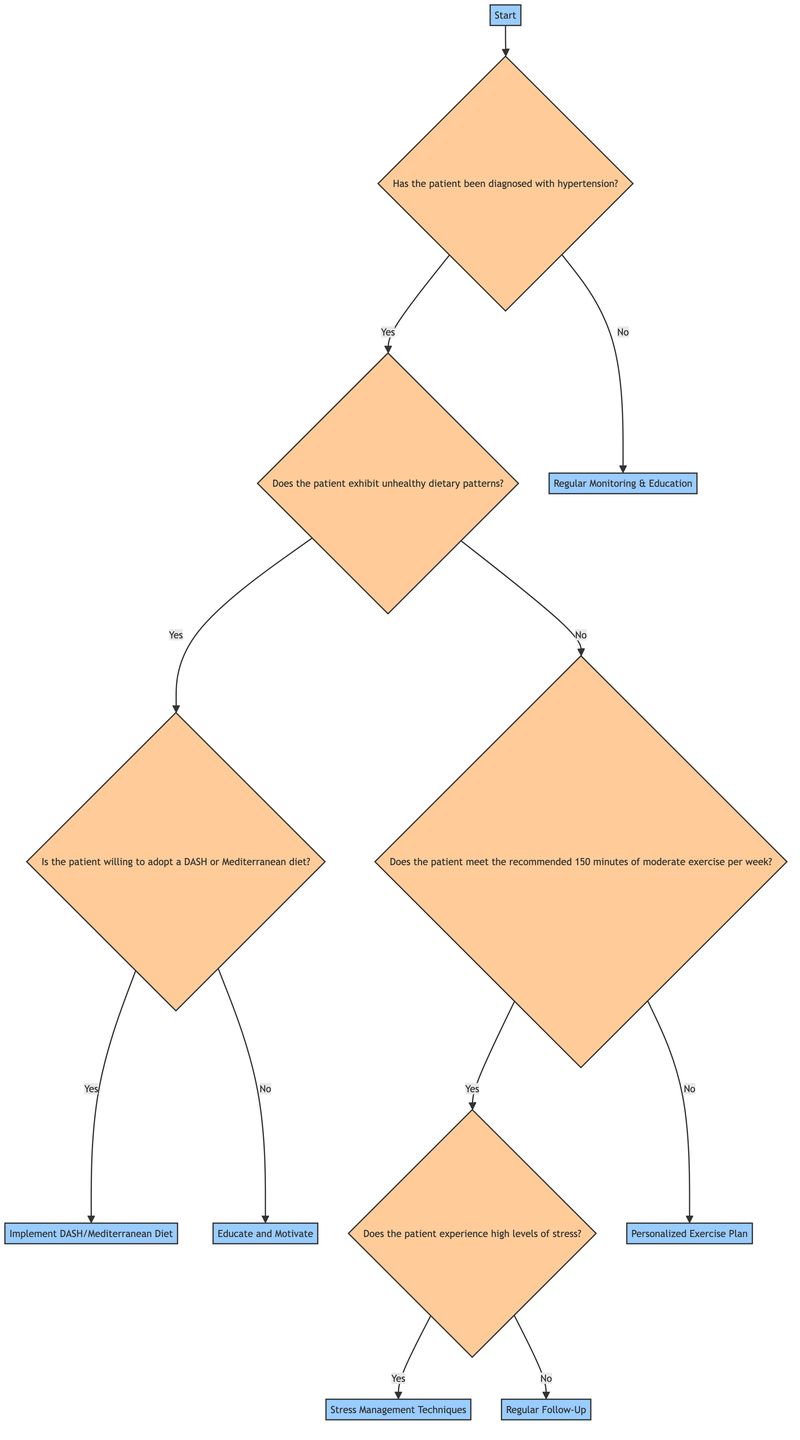What is the first question in the decision tree? The diagram begins with the node 'Start', which leads to the question “Has the patient been diagnosed with hypertension?”
Answer: Has the patient been diagnosed with hypertension? How many nodes are present in the entire diagram? Counting all distinct nodes from 'Start' to 'Regular Monitoring & Education', there are a total of 10 nodes.
Answer: 10 What action is suggested if the patient does not exhibit unhealthy dietary patterns? If the patient answers 'No' to the dietary patterns question, the tree indicates to 'Assess Physical Activity Level' as the next step.
Answer: Assess Physical Activity Level What is the outcome if a patient is willing to adopt a DASH or Mediterranean diet? If the patient answers 'Yes' to the willingness question, the suggested action is to 'Implement DASH/Mediterranean Diet', which leads to resource provision and monitoring.
Answer: Implement DASH/Mediterranean Diet If the patient meets the recommended exercise level, what is the next assessment? The decision tree shows that if the patient meets the exercise requirement, the next question is about assessing 'Stress Levels'.
Answer: Assess Stress Levels What happens if a patient does not have high levels of stress after assessment? If the patient does not experience high stress, the diagram states to proceed with 'Regular Follow-Up', which involves scheduling follow-up visits to monitor blood pressure.
Answer: Regular Follow-Up What action is recommended if the patient does not meet the 150-minute exercise recommendation? The diagram directs to create a 'Personalized Exercise Plan' as the next action step for those not meeting the exercise guidelines.
Answer: Personalized Exercise Plan What is the initial action taken if the patient is found not to have hypertension? The tree specifies that for patients not diagnosed with hypertension, the initial action is to provide 'Regular Monitoring & Education'.
Answer: Regular Monitoring & Education What is suggested for patients experiencing high levels of stress? For patients that answer 'Yes' to experiencing high stress, the diagram indicates to implement 'Stress Management Techniques'.
Answer: Stress Management Techniques 